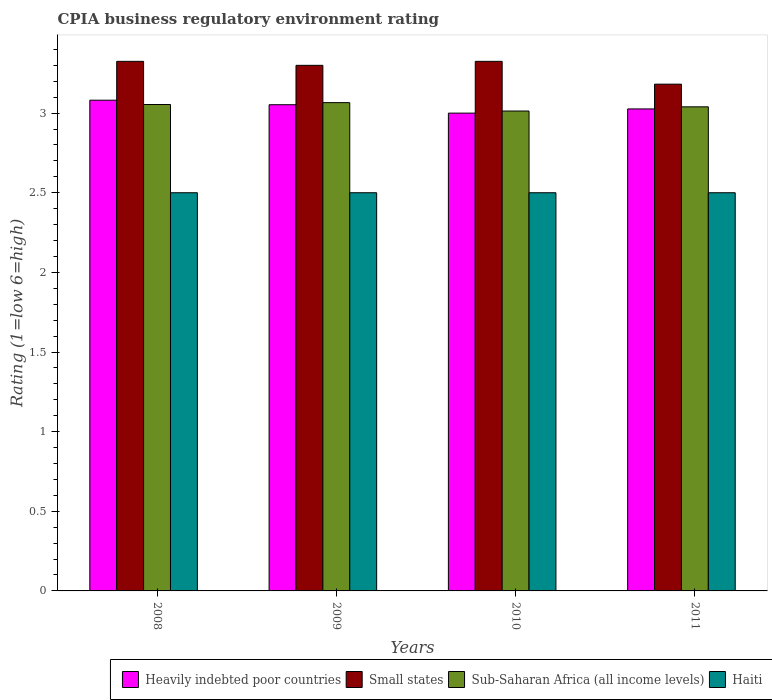How many different coloured bars are there?
Offer a very short reply. 4. How many groups of bars are there?
Your answer should be compact. 4. Are the number of bars per tick equal to the number of legend labels?
Provide a succinct answer. Yes. Are the number of bars on each tick of the X-axis equal?
Keep it short and to the point. Yes. How many bars are there on the 1st tick from the left?
Give a very brief answer. 4. What is the label of the 3rd group of bars from the left?
Give a very brief answer. 2010. In how many cases, is the number of bars for a given year not equal to the number of legend labels?
Offer a terse response. 0. What is the CPIA rating in Haiti in 2011?
Provide a succinct answer. 2.5. Across all years, what is the maximum CPIA rating in Sub-Saharan Africa (all income levels)?
Offer a very short reply. 3.07. Across all years, what is the minimum CPIA rating in Small states?
Provide a short and direct response. 3.18. In which year was the CPIA rating in Sub-Saharan Africa (all income levels) maximum?
Give a very brief answer. 2009. What is the total CPIA rating in Heavily indebted poor countries in the graph?
Keep it short and to the point. 12.16. What is the difference between the CPIA rating in Small states in 2008 and that in 2009?
Your answer should be compact. 0.03. What is the difference between the CPIA rating in Haiti in 2011 and the CPIA rating in Heavily indebted poor countries in 2008?
Keep it short and to the point. -0.58. What is the average CPIA rating in Sub-Saharan Africa (all income levels) per year?
Offer a very short reply. 3.04. In the year 2009, what is the difference between the CPIA rating in Heavily indebted poor countries and CPIA rating in Small states?
Offer a very short reply. -0.25. What is the ratio of the CPIA rating in Heavily indebted poor countries in 2010 to that in 2011?
Your answer should be compact. 0.99. What is the difference between the highest and the second highest CPIA rating in Heavily indebted poor countries?
Provide a succinct answer. 0.03. What is the difference between the highest and the lowest CPIA rating in Heavily indebted poor countries?
Your answer should be compact. 0.08. What does the 2nd bar from the left in 2011 represents?
Keep it short and to the point. Small states. What does the 2nd bar from the right in 2008 represents?
Keep it short and to the point. Sub-Saharan Africa (all income levels). Is it the case that in every year, the sum of the CPIA rating in Heavily indebted poor countries and CPIA rating in Haiti is greater than the CPIA rating in Sub-Saharan Africa (all income levels)?
Ensure brevity in your answer.  Yes. Are all the bars in the graph horizontal?
Your answer should be compact. No. How many years are there in the graph?
Your answer should be compact. 4. What is the difference between two consecutive major ticks on the Y-axis?
Give a very brief answer. 0.5. Where does the legend appear in the graph?
Give a very brief answer. Bottom right. What is the title of the graph?
Offer a very short reply. CPIA business regulatory environment rating. Does "Middle East & North Africa (all income levels)" appear as one of the legend labels in the graph?
Your answer should be very brief. No. What is the Rating (1=low 6=high) of Heavily indebted poor countries in 2008?
Offer a very short reply. 3.08. What is the Rating (1=low 6=high) of Small states in 2008?
Make the answer very short. 3.33. What is the Rating (1=low 6=high) in Sub-Saharan Africa (all income levels) in 2008?
Provide a short and direct response. 3.05. What is the Rating (1=low 6=high) of Heavily indebted poor countries in 2009?
Make the answer very short. 3.05. What is the Rating (1=low 6=high) in Sub-Saharan Africa (all income levels) in 2009?
Keep it short and to the point. 3.07. What is the Rating (1=low 6=high) of Haiti in 2009?
Make the answer very short. 2.5. What is the Rating (1=low 6=high) of Small states in 2010?
Provide a short and direct response. 3.33. What is the Rating (1=low 6=high) in Sub-Saharan Africa (all income levels) in 2010?
Your answer should be very brief. 3.01. What is the Rating (1=low 6=high) of Haiti in 2010?
Your response must be concise. 2.5. What is the Rating (1=low 6=high) in Heavily indebted poor countries in 2011?
Your response must be concise. 3.03. What is the Rating (1=low 6=high) in Small states in 2011?
Your answer should be compact. 3.18. What is the Rating (1=low 6=high) in Sub-Saharan Africa (all income levels) in 2011?
Your response must be concise. 3.04. What is the Rating (1=low 6=high) of Haiti in 2011?
Your answer should be compact. 2.5. Across all years, what is the maximum Rating (1=low 6=high) in Heavily indebted poor countries?
Your answer should be compact. 3.08. Across all years, what is the maximum Rating (1=low 6=high) of Small states?
Offer a very short reply. 3.33. Across all years, what is the maximum Rating (1=low 6=high) in Sub-Saharan Africa (all income levels)?
Make the answer very short. 3.07. Across all years, what is the minimum Rating (1=low 6=high) in Small states?
Provide a succinct answer. 3.18. Across all years, what is the minimum Rating (1=low 6=high) of Sub-Saharan Africa (all income levels)?
Your answer should be very brief. 3.01. What is the total Rating (1=low 6=high) of Heavily indebted poor countries in the graph?
Your answer should be very brief. 12.16. What is the total Rating (1=low 6=high) in Small states in the graph?
Your answer should be compact. 13.13. What is the total Rating (1=low 6=high) of Sub-Saharan Africa (all income levels) in the graph?
Your answer should be very brief. 12.17. What is the total Rating (1=low 6=high) of Haiti in the graph?
Offer a very short reply. 10. What is the difference between the Rating (1=low 6=high) in Heavily indebted poor countries in 2008 and that in 2009?
Offer a terse response. 0.03. What is the difference between the Rating (1=low 6=high) in Small states in 2008 and that in 2009?
Give a very brief answer. 0.03. What is the difference between the Rating (1=low 6=high) of Sub-Saharan Africa (all income levels) in 2008 and that in 2009?
Offer a terse response. -0.01. What is the difference between the Rating (1=low 6=high) in Heavily indebted poor countries in 2008 and that in 2010?
Your answer should be very brief. 0.08. What is the difference between the Rating (1=low 6=high) in Small states in 2008 and that in 2010?
Your answer should be very brief. 0. What is the difference between the Rating (1=low 6=high) in Sub-Saharan Africa (all income levels) in 2008 and that in 2010?
Give a very brief answer. 0.04. What is the difference between the Rating (1=low 6=high) in Heavily indebted poor countries in 2008 and that in 2011?
Give a very brief answer. 0.05. What is the difference between the Rating (1=low 6=high) in Small states in 2008 and that in 2011?
Your answer should be compact. 0.14. What is the difference between the Rating (1=low 6=high) in Sub-Saharan Africa (all income levels) in 2008 and that in 2011?
Offer a very short reply. 0.01. What is the difference between the Rating (1=low 6=high) in Haiti in 2008 and that in 2011?
Offer a very short reply. 0. What is the difference between the Rating (1=low 6=high) in Heavily indebted poor countries in 2009 and that in 2010?
Ensure brevity in your answer.  0.05. What is the difference between the Rating (1=low 6=high) in Small states in 2009 and that in 2010?
Give a very brief answer. -0.03. What is the difference between the Rating (1=low 6=high) of Sub-Saharan Africa (all income levels) in 2009 and that in 2010?
Ensure brevity in your answer.  0.05. What is the difference between the Rating (1=low 6=high) in Heavily indebted poor countries in 2009 and that in 2011?
Your answer should be very brief. 0.03. What is the difference between the Rating (1=low 6=high) in Small states in 2009 and that in 2011?
Your answer should be compact. 0.12. What is the difference between the Rating (1=low 6=high) of Sub-Saharan Africa (all income levels) in 2009 and that in 2011?
Your answer should be very brief. 0.03. What is the difference between the Rating (1=low 6=high) of Heavily indebted poor countries in 2010 and that in 2011?
Offer a terse response. -0.03. What is the difference between the Rating (1=low 6=high) in Small states in 2010 and that in 2011?
Provide a short and direct response. 0.14. What is the difference between the Rating (1=low 6=high) of Sub-Saharan Africa (all income levels) in 2010 and that in 2011?
Your response must be concise. -0.03. What is the difference between the Rating (1=low 6=high) in Heavily indebted poor countries in 2008 and the Rating (1=low 6=high) in Small states in 2009?
Keep it short and to the point. -0.22. What is the difference between the Rating (1=low 6=high) of Heavily indebted poor countries in 2008 and the Rating (1=low 6=high) of Sub-Saharan Africa (all income levels) in 2009?
Your answer should be compact. 0.02. What is the difference between the Rating (1=low 6=high) in Heavily indebted poor countries in 2008 and the Rating (1=low 6=high) in Haiti in 2009?
Your response must be concise. 0.58. What is the difference between the Rating (1=low 6=high) in Small states in 2008 and the Rating (1=low 6=high) in Sub-Saharan Africa (all income levels) in 2009?
Provide a short and direct response. 0.26. What is the difference between the Rating (1=low 6=high) in Small states in 2008 and the Rating (1=low 6=high) in Haiti in 2009?
Provide a succinct answer. 0.82. What is the difference between the Rating (1=low 6=high) of Sub-Saharan Africa (all income levels) in 2008 and the Rating (1=low 6=high) of Haiti in 2009?
Ensure brevity in your answer.  0.55. What is the difference between the Rating (1=low 6=high) of Heavily indebted poor countries in 2008 and the Rating (1=low 6=high) of Small states in 2010?
Provide a short and direct response. -0.24. What is the difference between the Rating (1=low 6=high) of Heavily indebted poor countries in 2008 and the Rating (1=low 6=high) of Sub-Saharan Africa (all income levels) in 2010?
Offer a terse response. 0.07. What is the difference between the Rating (1=low 6=high) of Heavily indebted poor countries in 2008 and the Rating (1=low 6=high) of Haiti in 2010?
Your answer should be compact. 0.58. What is the difference between the Rating (1=low 6=high) in Small states in 2008 and the Rating (1=low 6=high) in Sub-Saharan Africa (all income levels) in 2010?
Your response must be concise. 0.31. What is the difference between the Rating (1=low 6=high) of Small states in 2008 and the Rating (1=low 6=high) of Haiti in 2010?
Your answer should be compact. 0.82. What is the difference between the Rating (1=low 6=high) of Sub-Saharan Africa (all income levels) in 2008 and the Rating (1=low 6=high) of Haiti in 2010?
Ensure brevity in your answer.  0.55. What is the difference between the Rating (1=low 6=high) in Heavily indebted poor countries in 2008 and the Rating (1=low 6=high) in Small states in 2011?
Your answer should be compact. -0.1. What is the difference between the Rating (1=low 6=high) of Heavily indebted poor countries in 2008 and the Rating (1=low 6=high) of Sub-Saharan Africa (all income levels) in 2011?
Offer a terse response. 0.04. What is the difference between the Rating (1=low 6=high) of Heavily indebted poor countries in 2008 and the Rating (1=low 6=high) of Haiti in 2011?
Offer a terse response. 0.58. What is the difference between the Rating (1=low 6=high) of Small states in 2008 and the Rating (1=low 6=high) of Sub-Saharan Africa (all income levels) in 2011?
Ensure brevity in your answer.  0.29. What is the difference between the Rating (1=low 6=high) in Small states in 2008 and the Rating (1=low 6=high) in Haiti in 2011?
Your answer should be very brief. 0.82. What is the difference between the Rating (1=low 6=high) in Sub-Saharan Africa (all income levels) in 2008 and the Rating (1=low 6=high) in Haiti in 2011?
Your answer should be compact. 0.55. What is the difference between the Rating (1=low 6=high) in Heavily indebted poor countries in 2009 and the Rating (1=low 6=high) in Small states in 2010?
Give a very brief answer. -0.27. What is the difference between the Rating (1=low 6=high) in Heavily indebted poor countries in 2009 and the Rating (1=low 6=high) in Sub-Saharan Africa (all income levels) in 2010?
Offer a terse response. 0.04. What is the difference between the Rating (1=low 6=high) in Heavily indebted poor countries in 2009 and the Rating (1=low 6=high) in Haiti in 2010?
Your response must be concise. 0.55. What is the difference between the Rating (1=low 6=high) of Small states in 2009 and the Rating (1=low 6=high) of Sub-Saharan Africa (all income levels) in 2010?
Offer a very short reply. 0.29. What is the difference between the Rating (1=low 6=high) in Small states in 2009 and the Rating (1=low 6=high) in Haiti in 2010?
Provide a succinct answer. 0.8. What is the difference between the Rating (1=low 6=high) in Sub-Saharan Africa (all income levels) in 2009 and the Rating (1=low 6=high) in Haiti in 2010?
Your answer should be very brief. 0.57. What is the difference between the Rating (1=low 6=high) in Heavily indebted poor countries in 2009 and the Rating (1=low 6=high) in Small states in 2011?
Your answer should be compact. -0.13. What is the difference between the Rating (1=low 6=high) of Heavily indebted poor countries in 2009 and the Rating (1=low 6=high) of Sub-Saharan Africa (all income levels) in 2011?
Your response must be concise. 0.01. What is the difference between the Rating (1=low 6=high) of Heavily indebted poor countries in 2009 and the Rating (1=low 6=high) of Haiti in 2011?
Your answer should be very brief. 0.55. What is the difference between the Rating (1=low 6=high) in Small states in 2009 and the Rating (1=low 6=high) in Sub-Saharan Africa (all income levels) in 2011?
Your answer should be compact. 0.26. What is the difference between the Rating (1=low 6=high) in Sub-Saharan Africa (all income levels) in 2009 and the Rating (1=low 6=high) in Haiti in 2011?
Provide a short and direct response. 0.57. What is the difference between the Rating (1=low 6=high) in Heavily indebted poor countries in 2010 and the Rating (1=low 6=high) in Small states in 2011?
Provide a succinct answer. -0.18. What is the difference between the Rating (1=low 6=high) of Heavily indebted poor countries in 2010 and the Rating (1=low 6=high) of Sub-Saharan Africa (all income levels) in 2011?
Keep it short and to the point. -0.04. What is the difference between the Rating (1=low 6=high) in Small states in 2010 and the Rating (1=low 6=high) in Sub-Saharan Africa (all income levels) in 2011?
Give a very brief answer. 0.29. What is the difference between the Rating (1=low 6=high) of Small states in 2010 and the Rating (1=low 6=high) of Haiti in 2011?
Offer a very short reply. 0.82. What is the difference between the Rating (1=low 6=high) in Sub-Saharan Africa (all income levels) in 2010 and the Rating (1=low 6=high) in Haiti in 2011?
Offer a terse response. 0.51. What is the average Rating (1=low 6=high) in Heavily indebted poor countries per year?
Ensure brevity in your answer.  3.04. What is the average Rating (1=low 6=high) in Small states per year?
Ensure brevity in your answer.  3.28. What is the average Rating (1=low 6=high) in Sub-Saharan Africa (all income levels) per year?
Give a very brief answer. 3.04. What is the average Rating (1=low 6=high) in Haiti per year?
Keep it short and to the point. 2.5. In the year 2008, what is the difference between the Rating (1=low 6=high) in Heavily indebted poor countries and Rating (1=low 6=high) in Small states?
Offer a terse response. -0.24. In the year 2008, what is the difference between the Rating (1=low 6=high) of Heavily indebted poor countries and Rating (1=low 6=high) of Sub-Saharan Africa (all income levels)?
Keep it short and to the point. 0.03. In the year 2008, what is the difference between the Rating (1=low 6=high) in Heavily indebted poor countries and Rating (1=low 6=high) in Haiti?
Ensure brevity in your answer.  0.58. In the year 2008, what is the difference between the Rating (1=low 6=high) of Small states and Rating (1=low 6=high) of Sub-Saharan Africa (all income levels)?
Provide a succinct answer. 0.27. In the year 2008, what is the difference between the Rating (1=low 6=high) of Small states and Rating (1=low 6=high) of Haiti?
Your answer should be compact. 0.82. In the year 2008, what is the difference between the Rating (1=low 6=high) in Sub-Saharan Africa (all income levels) and Rating (1=low 6=high) in Haiti?
Keep it short and to the point. 0.55. In the year 2009, what is the difference between the Rating (1=low 6=high) in Heavily indebted poor countries and Rating (1=low 6=high) in Small states?
Give a very brief answer. -0.25. In the year 2009, what is the difference between the Rating (1=low 6=high) in Heavily indebted poor countries and Rating (1=low 6=high) in Sub-Saharan Africa (all income levels)?
Provide a succinct answer. -0.01. In the year 2009, what is the difference between the Rating (1=low 6=high) in Heavily indebted poor countries and Rating (1=low 6=high) in Haiti?
Your response must be concise. 0.55. In the year 2009, what is the difference between the Rating (1=low 6=high) of Small states and Rating (1=low 6=high) of Sub-Saharan Africa (all income levels)?
Give a very brief answer. 0.23. In the year 2009, what is the difference between the Rating (1=low 6=high) of Sub-Saharan Africa (all income levels) and Rating (1=low 6=high) of Haiti?
Your answer should be compact. 0.57. In the year 2010, what is the difference between the Rating (1=low 6=high) of Heavily indebted poor countries and Rating (1=low 6=high) of Small states?
Your answer should be compact. -0.33. In the year 2010, what is the difference between the Rating (1=low 6=high) of Heavily indebted poor countries and Rating (1=low 6=high) of Sub-Saharan Africa (all income levels)?
Keep it short and to the point. -0.01. In the year 2010, what is the difference between the Rating (1=low 6=high) in Heavily indebted poor countries and Rating (1=low 6=high) in Haiti?
Your answer should be compact. 0.5. In the year 2010, what is the difference between the Rating (1=low 6=high) in Small states and Rating (1=low 6=high) in Sub-Saharan Africa (all income levels)?
Provide a succinct answer. 0.31. In the year 2010, what is the difference between the Rating (1=low 6=high) in Small states and Rating (1=low 6=high) in Haiti?
Provide a short and direct response. 0.82. In the year 2010, what is the difference between the Rating (1=low 6=high) in Sub-Saharan Africa (all income levels) and Rating (1=low 6=high) in Haiti?
Your answer should be compact. 0.51. In the year 2011, what is the difference between the Rating (1=low 6=high) in Heavily indebted poor countries and Rating (1=low 6=high) in Small states?
Offer a terse response. -0.16. In the year 2011, what is the difference between the Rating (1=low 6=high) of Heavily indebted poor countries and Rating (1=low 6=high) of Sub-Saharan Africa (all income levels)?
Provide a succinct answer. -0.01. In the year 2011, what is the difference between the Rating (1=low 6=high) of Heavily indebted poor countries and Rating (1=low 6=high) of Haiti?
Provide a succinct answer. 0.53. In the year 2011, what is the difference between the Rating (1=low 6=high) of Small states and Rating (1=low 6=high) of Sub-Saharan Africa (all income levels)?
Your response must be concise. 0.14. In the year 2011, what is the difference between the Rating (1=low 6=high) in Small states and Rating (1=low 6=high) in Haiti?
Keep it short and to the point. 0.68. In the year 2011, what is the difference between the Rating (1=low 6=high) of Sub-Saharan Africa (all income levels) and Rating (1=low 6=high) of Haiti?
Your response must be concise. 0.54. What is the ratio of the Rating (1=low 6=high) of Heavily indebted poor countries in 2008 to that in 2009?
Your answer should be very brief. 1.01. What is the ratio of the Rating (1=low 6=high) of Small states in 2008 to that in 2009?
Give a very brief answer. 1.01. What is the ratio of the Rating (1=low 6=high) of Sub-Saharan Africa (all income levels) in 2008 to that in 2009?
Offer a very short reply. 1. What is the ratio of the Rating (1=low 6=high) in Haiti in 2008 to that in 2009?
Your response must be concise. 1. What is the ratio of the Rating (1=low 6=high) of Heavily indebted poor countries in 2008 to that in 2010?
Your answer should be compact. 1.03. What is the ratio of the Rating (1=low 6=high) in Small states in 2008 to that in 2010?
Your answer should be very brief. 1. What is the ratio of the Rating (1=low 6=high) in Sub-Saharan Africa (all income levels) in 2008 to that in 2010?
Keep it short and to the point. 1.01. What is the ratio of the Rating (1=low 6=high) in Haiti in 2008 to that in 2010?
Give a very brief answer. 1. What is the ratio of the Rating (1=low 6=high) of Heavily indebted poor countries in 2008 to that in 2011?
Your answer should be compact. 1.02. What is the ratio of the Rating (1=low 6=high) in Small states in 2008 to that in 2011?
Your answer should be compact. 1.04. What is the ratio of the Rating (1=low 6=high) of Sub-Saharan Africa (all income levels) in 2008 to that in 2011?
Your response must be concise. 1. What is the ratio of the Rating (1=low 6=high) of Heavily indebted poor countries in 2009 to that in 2010?
Offer a very short reply. 1.02. What is the ratio of the Rating (1=low 6=high) in Small states in 2009 to that in 2010?
Provide a short and direct response. 0.99. What is the ratio of the Rating (1=low 6=high) in Sub-Saharan Africa (all income levels) in 2009 to that in 2010?
Your answer should be compact. 1.02. What is the ratio of the Rating (1=low 6=high) in Haiti in 2009 to that in 2010?
Provide a succinct answer. 1. What is the ratio of the Rating (1=low 6=high) in Heavily indebted poor countries in 2009 to that in 2011?
Provide a succinct answer. 1.01. What is the ratio of the Rating (1=low 6=high) in Small states in 2009 to that in 2011?
Offer a very short reply. 1.04. What is the ratio of the Rating (1=low 6=high) of Sub-Saharan Africa (all income levels) in 2009 to that in 2011?
Your answer should be very brief. 1.01. What is the ratio of the Rating (1=low 6=high) of Haiti in 2009 to that in 2011?
Ensure brevity in your answer.  1. What is the ratio of the Rating (1=low 6=high) in Heavily indebted poor countries in 2010 to that in 2011?
Offer a very short reply. 0.99. What is the ratio of the Rating (1=low 6=high) of Small states in 2010 to that in 2011?
Your answer should be compact. 1.04. What is the difference between the highest and the second highest Rating (1=low 6=high) of Heavily indebted poor countries?
Keep it short and to the point. 0.03. What is the difference between the highest and the second highest Rating (1=low 6=high) in Small states?
Keep it short and to the point. 0. What is the difference between the highest and the second highest Rating (1=low 6=high) of Sub-Saharan Africa (all income levels)?
Ensure brevity in your answer.  0.01. What is the difference between the highest and the second highest Rating (1=low 6=high) of Haiti?
Make the answer very short. 0. What is the difference between the highest and the lowest Rating (1=low 6=high) of Heavily indebted poor countries?
Provide a short and direct response. 0.08. What is the difference between the highest and the lowest Rating (1=low 6=high) in Small states?
Your response must be concise. 0.14. What is the difference between the highest and the lowest Rating (1=low 6=high) of Sub-Saharan Africa (all income levels)?
Provide a short and direct response. 0.05. What is the difference between the highest and the lowest Rating (1=low 6=high) of Haiti?
Offer a very short reply. 0. 